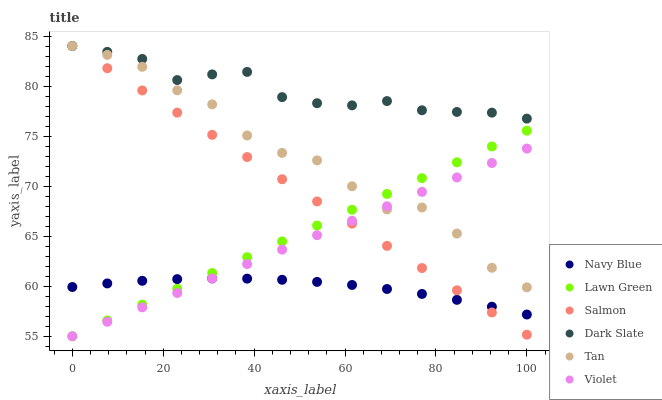Does Navy Blue have the minimum area under the curve?
Answer yes or no. Yes. Does Dark Slate have the maximum area under the curve?
Answer yes or no. Yes. Does Salmon have the minimum area under the curve?
Answer yes or no. No. Does Salmon have the maximum area under the curve?
Answer yes or no. No. Is Lawn Green the smoothest?
Answer yes or no. Yes. Is Tan the roughest?
Answer yes or no. Yes. Is Navy Blue the smoothest?
Answer yes or no. No. Is Navy Blue the roughest?
Answer yes or no. No. Does Lawn Green have the lowest value?
Answer yes or no. Yes. Does Navy Blue have the lowest value?
Answer yes or no. No. Does Tan have the highest value?
Answer yes or no. Yes. Does Navy Blue have the highest value?
Answer yes or no. No. Is Navy Blue less than Tan?
Answer yes or no. Yes. Is Dark Slate greater than Navy Blue?
Answer yes or no. Yes. Does Salmon intersect Tan?
Answer yes or no. Yes. Is Salmon less than Tan?
Answer yes or no. No. Is Salmon greater than Tan?
Answer yes or no. No. Does Navy Blue intersect Tan?
Answer yes or no. No. 